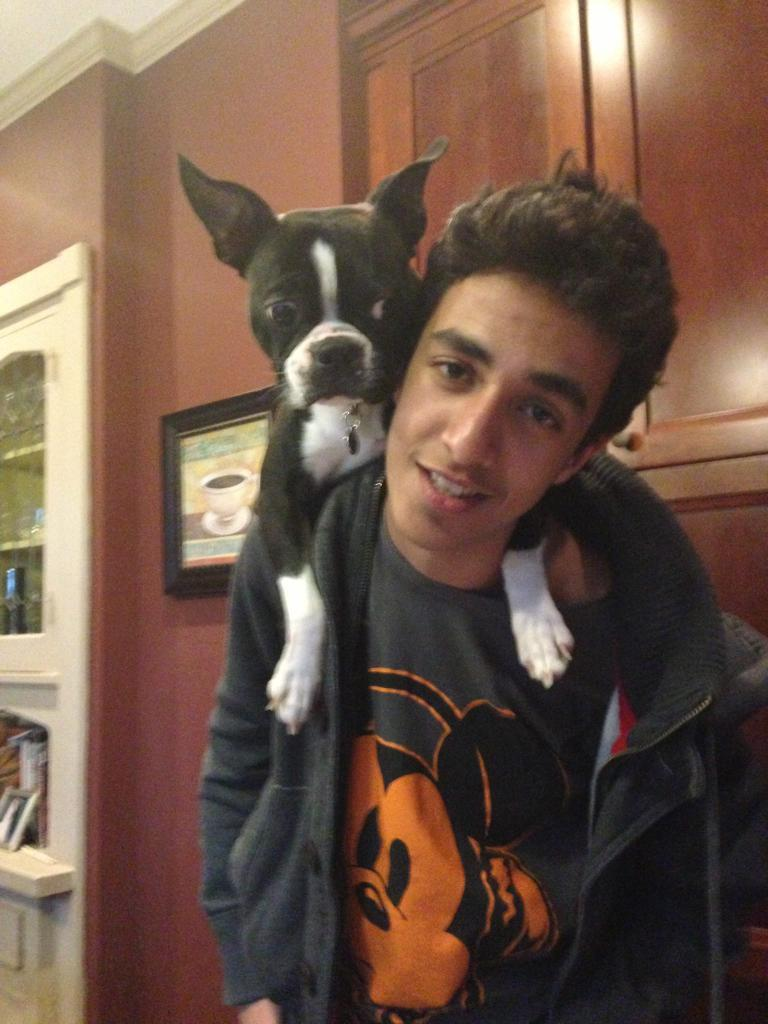Who or what is in the image? There is a person in the image. What is on the person? A rock is on the person. What can be seen on the wall in the background? There is a frame on the wall in the background. What type of furniture is visible in the background? There is a cupboard in the background. What else can be seen in the background? There are objects visible in the background. What type of lettuce is growing on the person's head in the image? There is no lettuce growing on the person's head in the image; it is a rock on the person. 